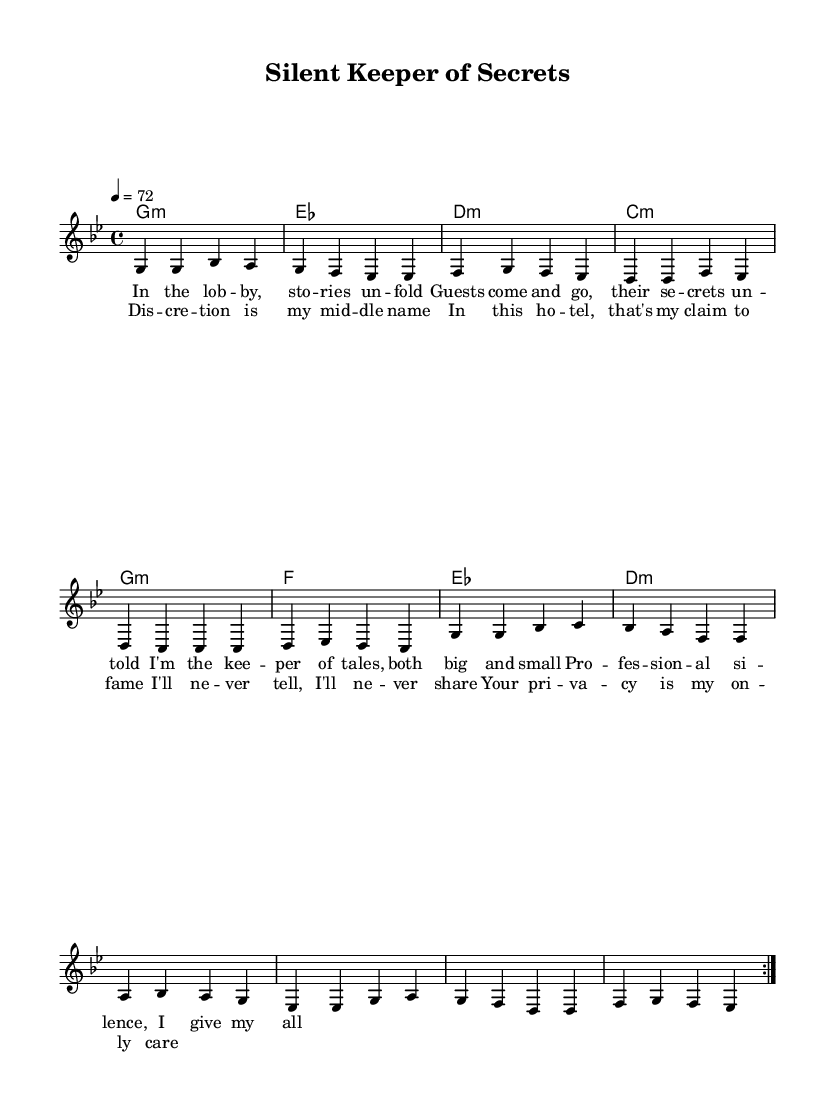What is the key signature of this music? The key signature is G minor, which has two flats indicated by the positions of B flat and E flat on the staff.
Answer: G minor What is the time signature of this music? The time signature is indicated as 4/4, which means there are four beats in each measure and the quarter note gets one beat.
Answer: 4/4 What is the tempo of this music? The tempo marking shows 4 = 72, which means there are 72 quarter note beats per minute.
Answer: 72 How many volta sections are there in the melody? The music features a repeat indication marked "volta," and there are two repeats specified, indicating there are two sections to play.
Answer: 2 What is the title of this piece? The title is presented in the header section as "Silent Keeper of Secrets." This indicates the thematic content of the piece as well.
Answer: Silent Keeper of Secrets What is the professional theme expressed in the lyrics? The lyrics emphasize the importance of discretion and professionalism in the hospitality industry, reflecting the values of privacy and confidentiality.
Answer: Discretion What genre does this composition belong to? The sheet music is described as having elements typical of reggae, specifically roots reggae, indicated by the chord progressions and lyrical themes.
Answer: Reggae 